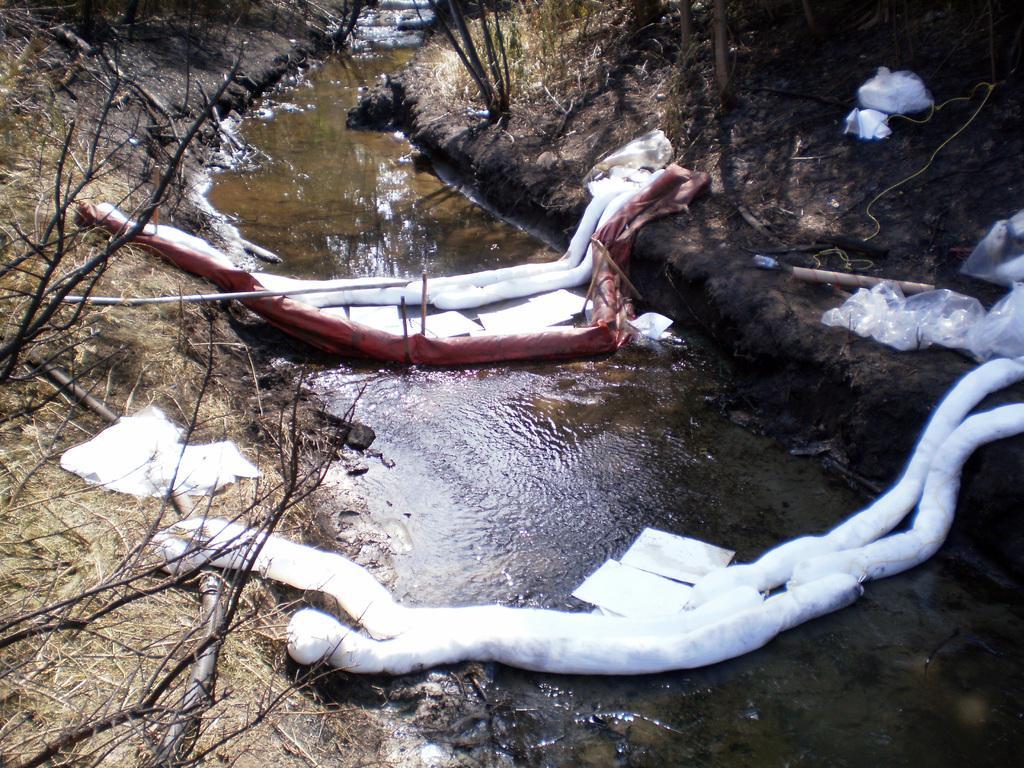Could you give a brief overview of what you see in this image? This image consists of an objects which are white in colour in the center. There is water in the background and on the left side there are dry trees. On the right side there is dry grass. 